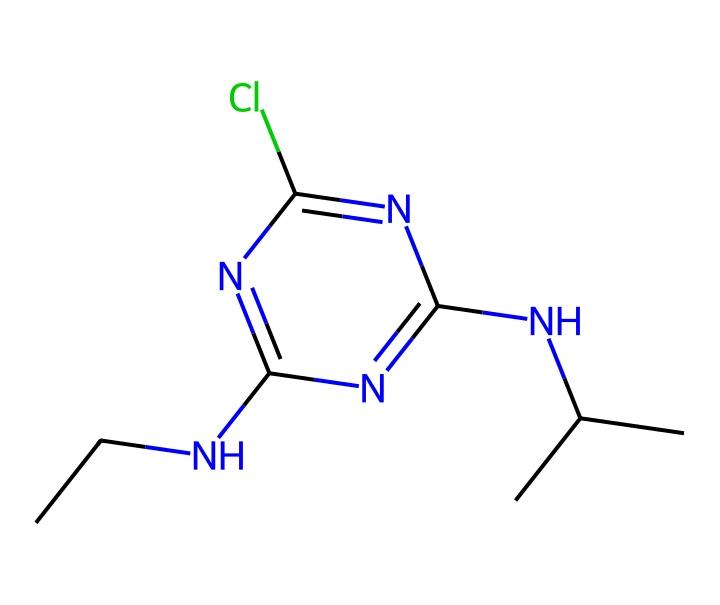What is the molecular formula of atrazine? By analyzing the SMILES representation, we can count the atoms present: There are 10 carbon (C), 14 hydrogen (H), 2 nitrogen (N), 1 chlorine (Cl), and 2 additional nitrogen atoms. Therefore, the molecular formula is C8H14ClN5.
Answer: C8H14ClN5 How many nitrogen atoms are present in atrazine? The SMILES notation shows two nitrogen atoms in the chain, recognizable as "N", and two additional nitrogen atoms in the cyclic structure. In total, there are four nitrogen atoms.
Answer: 4 What type of chemical is atrazine? Atrazine is classified as a herbicide, specifically a chlorotriazine compound, due to its function in weed control and its chemical structure which includes triazine rings.
Answer: herbicide What is the role of chlorine in the atrazine structure? The chlorine atom in the atrazine structure plays a critical role in enhancing the herbicide's effectiveness, contributing to its hydrophobic properties, which facilitate penetration into plant cuticles.
Answer: enhance effectiveness How many rings are present in the atrazine structure? Inspecting the SMILES representation reveals a single six-membered ring containing nitrogen atoms, which is characteristic of triazine compounds. Hence, there is one ring present in this chemical.
Answer: 1 What might be a consequence of atrazine contamination in water sources? Atrazine is linked to potential health risks including endocrine disruption and developmental issues in aquatic life, which are serious environmental and public health concerns stemming from its contamination of water sources.
Answer: health risks 